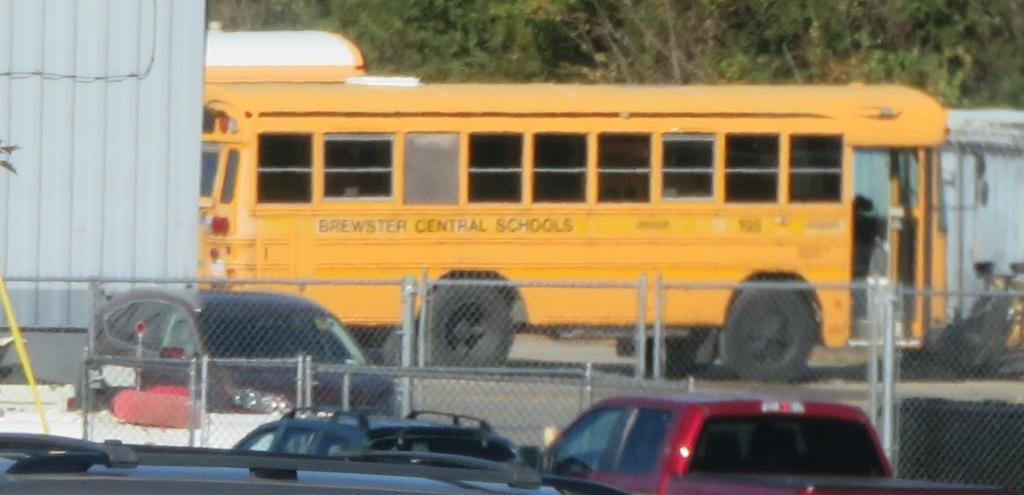What type of vehicles can be seen in the image? There are cars in the image. What is in front of the cars? There is fencing in front of the cars. What other type of vehicle is present in the image? There is a school bus in the middle of the image. What type of vegetation can be seen in the background of the image? There are trees visible in the background of the image. What book is the worm reading in the image? There is no book or worm present in the image. 